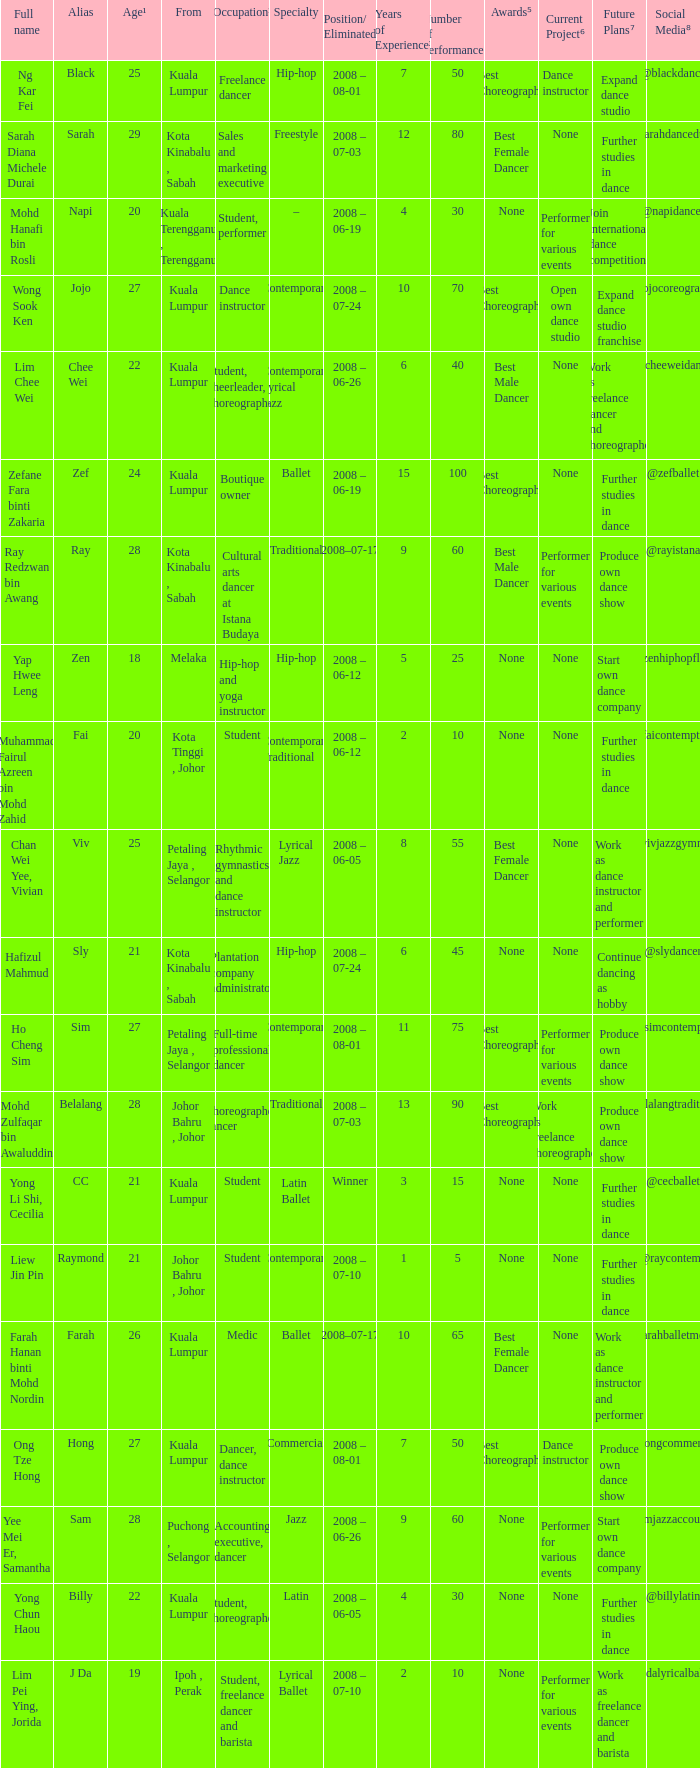What is Position/ Eliminated, when From is "Kuala Lumpur", and when Specialty is "Contemporary Lyrical Jazz"? 2008 – 06-26. 